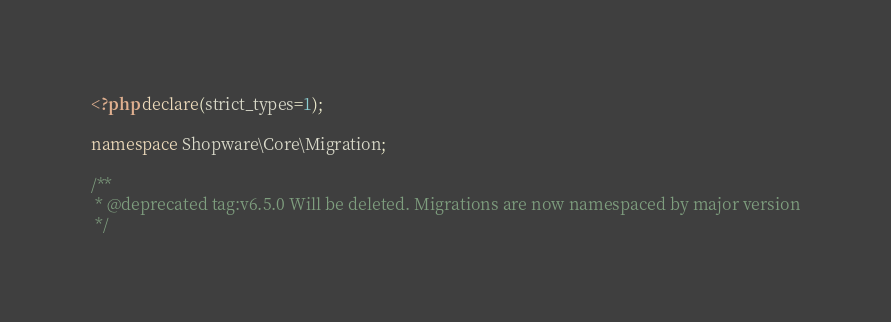Convert code to text. <code><loc_0><loc_0><loc_500><loc_500><_PHP_><?php declare(strict_types=1);

namespace Shopware\Core\Migration;

/**
 * @deprecated tag:v6.5.0 Will be deleted. Migrations are now namespaced by major version
 */</code> 